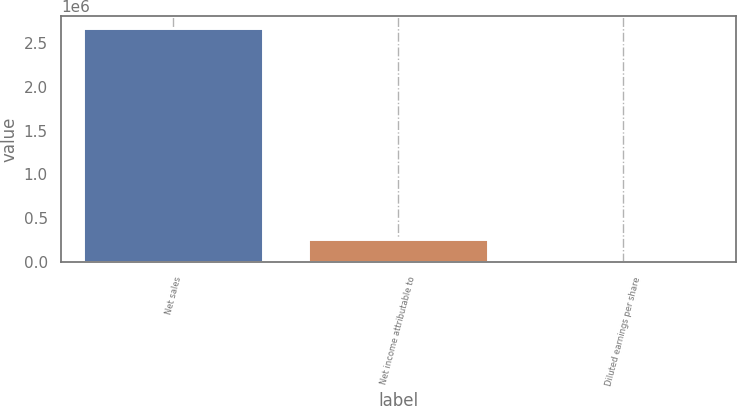Convert chart. <chart><loc_0><loc_0><loc_500><loc_500><bar_chart><fcel>Net sales<fcel>Net income attributable to<fcel>Diluted earnings per share<nl><fcel>2.6708e+06<fcel>267082<fcel>1.78<nl></chart> 